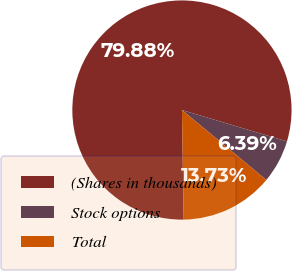Convert chart to OTSL. <chart><loc_0><loc_0><loc_500><loc_500><pie_chart><fcel>(Shares in thousands)<fcel>Stock options<fcel>Total<nl><fcel>79.88%<fcel>6.39%<fcel>13.73%<nl></chart> 